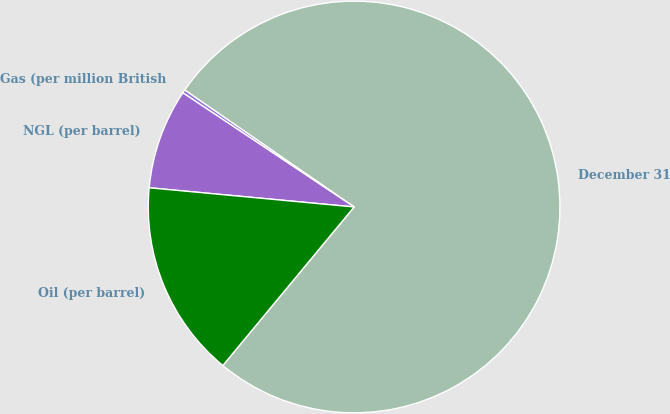Convert chart. <chart><loc_0><loc_0><loc_500><loc_500><pie_chart><fcel>December 31<fcel>Gas (per million British<fcel>NGL (per barrel)<fcel>Oil (per barrel)<nl><fcel>76.39%<fcel>0.26%<fcel>7.87%<fcel>15.48%<nl></chart> 